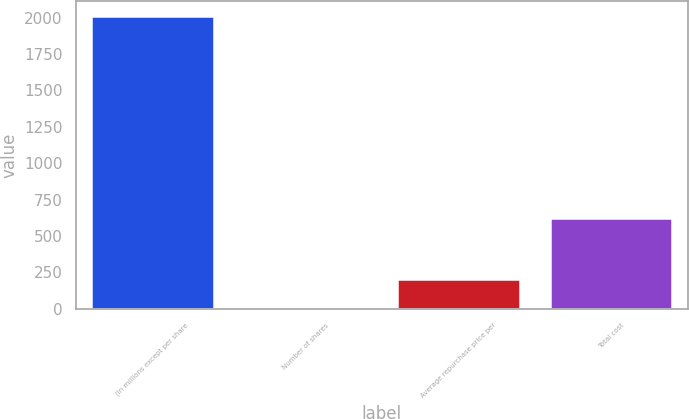Convert chart. <chart><loc_0><loc_0><loc_500><loc_500><bar_chart><fcel>(In millions except per share<fcel>Number of shares<fcel>Average repurchase price per<fcel>Total cost<nl><fcel>2014<fcel>7.8<fcel>208.42<fcel>624<nl></chart> 